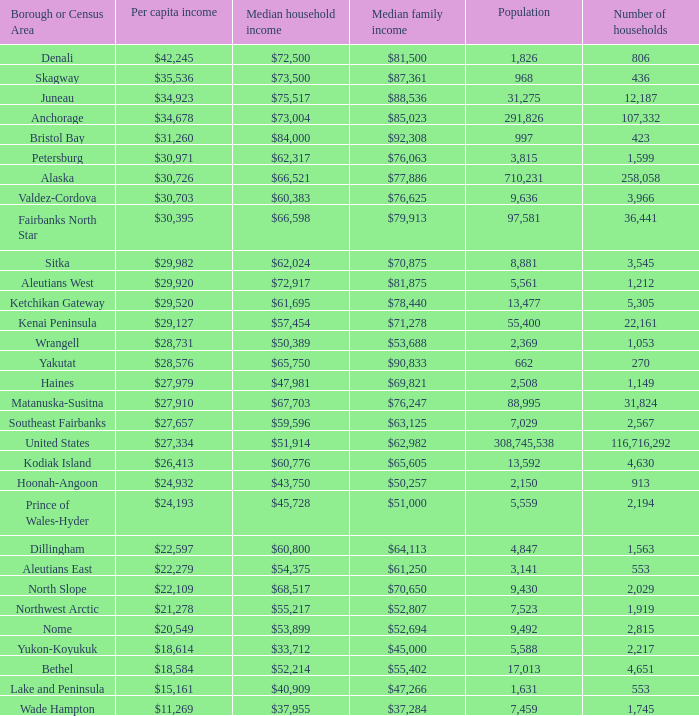Parse the table in full. {'header': ['Borough or Census Area', 'Per capita income', 'Median household income', 'Median family income', 'Population', 'Number of households'], 'rows': [['Denali', '$42,245', '$72,500', '$81,500', '1,826', '806'], ['Skagway', '$35,536', '$73,500', '$87,361', '968', '436'], ['Juneau', '$34,923', '$75,517', '$88,536', '31,275', '12,187'], ['Anchorage', '$34,678', '$73,004', '$85,023', '291,826', '107,332'], ['Bristol Bay', '$31,260', '$84,000', '$92,308', '997', '423'], ['Petersburg', '$30,971', '$62,317', '$76,063', '3,815', '1,599'], ['Alaska', '$30,726', '$66,521', '$77,886', '710,231', '258,058'], ['Valdez-Cordova', '$30,703', '$60,383', '$76,625', '9,636', '3,966'], ['Fairbanks North Star', '$30,395', '$66,598', '$79,913', '97,581', '36,441'], ['Sitka', '$29,982', '$62,024', '$70,875', '8,881', '3,545'], ['Aleutians West', '$29,920', '$72,917', '$81,875', '5,561', '1,212'], ['Ketchikan Gateway', '$29,520', '$61,695', '$78,440', '13,477', '5,305'], ['Kenai Peninsula', '$29,127', '$57,454', '$71,278', '55,400', '22,161'], ['Wrangell', '$28,731', '$50,389', '$53,688', '2,369', '1,053'], ['Yakutat', '$28,576', '$65,750', '$90,833', '662', '270'], ['Haines', '$27,979', '$47,981', '$69,821', '2,508', '1,149'], ['Matanuska-Susitna', '$27,910', '$67,703', '$76,247', '88,995', '31,824'], ['Southeast Fairbanks', '$27,657', '$59,596', '$63,125', '7,029', '2,567'], ['United States', '$27,334', '$51,914', '$62,982', '308,745,538', '116,716,292'], ['Kodiak Island', '$26,413', '$60,776', '$65,605', '13,592', '4,630'], ['Hoonah-Angoon', '$24,932', '$43,750', '$50,257', '2,150', '913'], ['Prince of Wales-Hyder', '$24,193', '$45,728', '$51,000', '5,559', '2,194'], ['Dillingham', '$22,597', '$60,800', '$64,113', '4,847', '1,563'], ['Aleutians East', '$22,279', '$54,375', '$61,250', '3,141', '553'], ['North Slope', '$22,109', '$68,517', '$70,650', '9,430', '2,029'], ['Northwest Arctic', '$21,278', '$55,217', '$52,807', '7,523', '1,919'], ['Nome', '$20,549', '$53,899', '$52,694', '9,492', '2,815'], ['Yukon-Koyukuk', '$18,614', '$33,712', '$45,000', '5,588', '2,217'], ['Bethel', '$18,584', '$52,214', '$55,402', '17,013', '4,651'], ['Lake and Peninsula', '$15,161', '$40,909', '$47,266', '1,631', '553'], ['Wade Hampton', '$11,269', '$37,955', '$37,284', '7,459', '1,745']]} What is the population of the region with a median family income of $71,278? 1.0. 